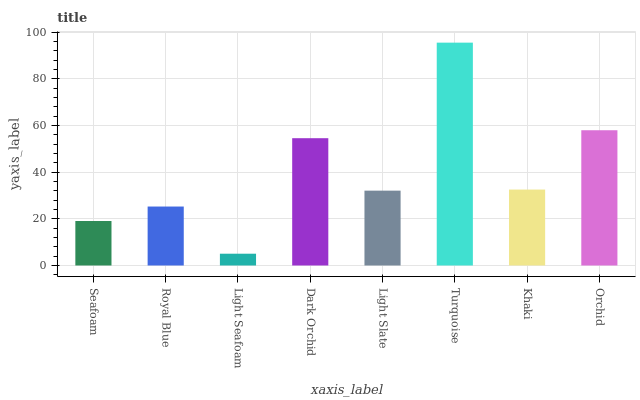Is Light Seafoam the minimum?
Answer yes or no. Yes. Is Turquoise the maximum?
Answer yes or no. Yes. Is Royal Blue the minimum?
Answer yes or no. No. Is Royal Blue the maximum?
Answer yes or no. No. Is Royal Blue greater than Seafoam?
Answer yes or no. Yes. Is Seafoam less than Royal Blue?
Answer yes or no. Yes. Is Seafoam greater than Royal Blue?
Answer yes or no. No. Is Royal Blue less than Seafoam?
Answer yes or no. No. Is Khaki the high median?
Answer yes or no. Yes. Is Light Slate the low median?
Answer yes or no. Yes. Is Turquoise the high median?
Answer yes or no. No. Is Light Seafoam the low median?
Answer yes or no. No. 